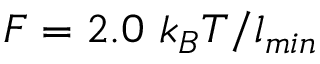<formula> <loc_0><loc_0><loc_500><loc_500>F = 2 . 0 k _ { B } T / l _ { \min }</formula> 